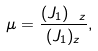Convert formula to latex. <formula><loc_0><loc_0><loc_500><loc_500>\mu = \frac { ( J _ { 1 } ) _ { \ z } } { ( J _ { 1 } ) _ { z } } ,</formula> 